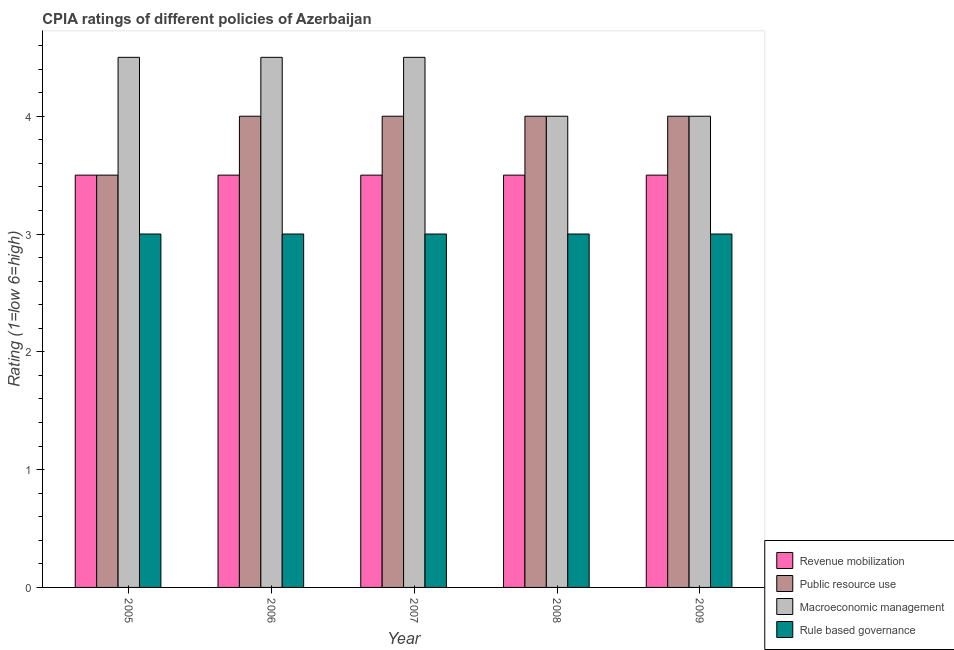How many different coloured bars are there?
Provide a succinct answer. 4. Are the number of bars per tick equal to the number of legend labels?
Make the answer very short. Yes. Are the number of bars on each tick of the X-axis equal?
Make the answer very short. Yes. What is the label of the 2nd group of bars from the left?
Provide a short and direct response. 2006. What is the cpia rating of revenue mobilization in 2006?
Offer a very short reply. 3.5. Across all years, what is the minimum cpia rating of rule based governance?
Provide a succinct answer. 3. What is the total cpia rating of public resource use in the graph?
Give a very brief answer. 19.5. What is the difference between the cpia rating of revenue mobilization in 2005 and the cpia rating of rule based governance in 2006?
Provide a succinct answer. 0. In how many years, is the cpia rating of rule based governance greater than 0.8?
Your answer should be compact. 5. What is the ratio of the cpia rating of public resource use in 2007 to that in 2009?
Provide a succinct answer. 1. Is the difference between the cpia rating of public resource use in 2005 and 2007 greater than the difference between the cpia rating of macroeconomic management in 2005 and 2007?
Provide a succinct answer. No. Is the sum of the cpia rating of public resource use in 2007 and 2008 greater than the maximum cpia rating of rule based governance across all years?
Offer a terse response. Yes. What does the 1st bar from the left in 2009 represents?
Offer a terse response. Revenue mobilization. What does the 1st bar from the right in 2008 represents?
Keep it short and to the point. Rule based governance. How many years are there in the graph?
Keep it short and to the point. 5. What is the difference between two consecutive major ticks on the Y-axis?
Provide a short and direct response. 1. Are the values on the major ticks of Y-axis written in scientific E-notation?
Offer a terse response. No. Does the graph contain grids?
Your response must be concise. No. How are the legend labels stacked?
Keep it short and to the point. Vertical. What is the title of the graph?
Your response must be concise. CPIA ratings of different policies of Azerbaijan. Does "Corruption" appear as one of the legend labels in the graph?
Your answer should be compact. No. What is the label or title of the X-axis?
Ensure brevity in your answer.  Year. What is the label or title of the Y-axis?
Make the answer very short. Rating (1=low 6=high). What is the Rating (1=low 6=high) of Revenue mobilization in 2005?
Ensure brevity in your answer.  3.5. What is the Rating (1=low 6=high) of Public resource use in 2005?
Offer a terse response. 3.5. What is the Rating (1=low 6=high) of Macroeconomic management in 2005?
Provide a short and direct response. 4.5. What is the Rating (1=low 6=high) of Macroeconomic management in 2006?
Offer a terse response. 4.5. What is the Rating (1=low 6=high) of Public resource use in 2008?
Provide a short and direct response. 4. What is the Rating (1=low 6=high) in Rule based governance in 2008?
Give a very brief answer. 3. What is the Rating (1=low 6=high) of Revenue mobilization in 2009?
Give a very brief answer. 3.5. What is the Rating (1=low 6=high) of Public resource use in 2009?
Make the answer very short. 4. Across all years, what is the maximum Rating (1=low 6=high) in Revenue mobilization?
Provide a short and direct response. 3.5. Across all years, what is the maximum Rating (1=low 6=high) of Public resource use?
Offer a very short reply. 4. Across all years, what is the maximum Rating (1=low 6=high) in Rule based governance?
Offer a very short reply. 3. Across all years, what is the minimum Rating (1=low 6=high) of Revenue mobilization?
Keep it short and to the point. 3.5. Across all years, what is the minimum Rating (1=low 6=high) in Macroeconomic management?
Your answer should be compact. 4. Across all years, what is the minimum Rating (1=low 6=high) in Rule based governance?
Ensure brevity in your answer.  3. What is the total Rating (1=low 6=high) of Revenue mobilization in the graph?
Offer a very short reply. 17.5. What is the total Rating (1=low 6=high) in Macroeconomic management in the graph?
Your response must be concise. 21.5. What is the total Rating (1=low 6=high) of Rule based governance in the graph?
Offer a very short reply. 15. What is the difference between the Rating (1=low 6=high) in Public resource use in 2005 and that in 2006?
Make the answer very short. -0.5. What is the difference between the Rating (1=low 6=high) in Macroeconomic management in 2005 and that in 2006?
Keep it short and to the point. 0. What is the difference between the Rating (1=low 6=high) of Macroeconomic management in 2005 and that in 2007?
Ensure brevity in your answer.  0. What is the difference between the Rating (1=low 6=high) in Rule based governance in 2005 and that in 2007?
Make the answer very short. 0. What is the difference between the Rating (1=low 6=high) in Revenue mobilization in 2005 and that in 2008?
Give a very brief answer. 0. What is the difference between the Rating (1=low 6=high) of Public resource use in 2005 and that in 2008?
Your response must be concise. -0.5. What is the difference between the Rating (1=low 6=high) in Macroeconomic management in 2005 and that in 2008?
Your answer should be very brief. 0.5. What is the difference between the Rating (1=low 6=high) of Public resource use in 2005 and that in 2009?
Keep it short and to the point. -0.5. What is the difference between the Rating (1=low 6=high) of Rule based governance in 2005 and that in 2009?
Your answer should be compact. 0. What is the difference between the Rating (1=low 6=high) of Public resource use in 2006 and that in 2007?
Your answer should be very brief. 0. What is the difference between the Rating (1=low 6=high) of Macroeconomic management in 2006 and that in 2007?
Your answer should be very brief. 0. What is the difference between the Rating (1=low 6=high) of Rule based governance in 2006 and that in 2007?
Keep it short and to the point. 0. What is the difference between the Rating (1=low 6=high) in Public resource use in 2006 and that in 2008?
Provide a short and direct response. 0. What is the difference between the Rating (1=low 6=high) of Macroeconomic management in 2006 and that in 2008?
Offer a terse response. 0.5. What is the difference between the Rating (1=low 6=high) of Rule based governance in 2006 and that in 2008?
Your answer should be very brief. 0. What is the difference between the Rating (1=low 6=high) in Macroeconomic management in 2006 and that in 2009?
Ensure brevity in your answer.  0.5. What is the difference between the Rating (1=low 6=high) of Rule based governance in 2006 and that in 2009?
Ensure brevity in your answer.  0. What is the difference between the Rating (1=low 6=high) of Macroeconomic management in 2007 and that in 2008?
Make the answer very short. 0.5. What is the difference between the Rating (1=low 6=high) in Revenue mobilization in 2007 and that in 2009?
Keep it short and to the point. 0. What is the difference between the Rating (1=low 6=high) of Public resource use in 2007 and that in 2009?
Keep it short and to the point. 0. What is the difference between the Rating (1=low 6=high) of Macroeconomic management in 2008 and that in 2009?
Make the answer very short. 0. What is the difference between the Rating (1=low 6=high) of Public resource use in 2005 and the Rating (1=low 6=high) of Macroeconomic management in 2006?
Give a very brief answer. -1. What is the difference between the Rating (1=low 6=high) of Public resource use in 2005 and the Rating (1=low 6=high) of Rule based governance in 2006?
Offer a terse response. 0.5. What is the difference between the Rating (1=low 6=high) of Public resource use in 2005 and the Rating (1=low 6=high) of Macroeconomic management in 2007?
Offer a terse response. -1. What is the difference between the Rating (1=low 6=high) in Public resource use in 2005 and the Rating (1=low 6=high) in Rule based governance in 2007?
Offer a very short reply. 0.5. What is the difference between the Rating (1=low 6=high) in Revenue mobilization in 2005 and the Rating (1=low 6=high) in Macroeconomic management in 2008?
Offer a terse response. -0.5. What is the difference between the Rating (1=low 6=high) in Revenue mobilization in 2005 and the Rating (1=low 6=high) in Rule based governance in 2008?
Offer a very short reply. 0.5. What is the difference between the Rating (1=low 6=high) of Revenue mobilization in 2005 and the Rating (1=low 6=high) of Public resource use in 2009?
Provide a short and direct response. -0.5. What is the difference between the Rating (1=low 6=high) of Revenue mobilization in 2005 and the Rating (1=low 6=high) of Rule based governance in 2009?
Offer a terse response. 0.5. What is the difference between the Rating (1=low 6=high) in Macroeconomic management in 2005 and the Rating (1=low 6=high) in Rule based governance in 2009?
Give a very brief answer. 1.5. What is the difference between the Rating (1=low 6=high) in Revenue mobilization in 2006 and the Rating (1=low 6=high) in Macroeconomic management in 2007?
Offer a terse response. -1. What is the difference between the Rating (1=low 6=high) of Revenue mobilization in 2006 and the Rating (1=low 6=high) of Public resource use in 2008?
Your response must be concise. -0.5. What is the difference between the Rating (1=low 6=high) of Revenue mobilization in 2006 and the Rating (1=low 6=high) of Macroeconomic management in 2008?
Your response must be concise. -0.5. What is the difference between the Rating (1=low 6=high) of Public resource use in 2006 and the Rating (1=low 6=high) of Macroeconomic management in 2008?
Give a very brief answer. 0. What is the difference between the Rating (1=low 6=high) of Revenue mobilization in 2006 and the Rating (1=low 6=high) of Macroeconomic management in 2009?
Make the answer very short. -0.5. What is the difference between the Rating (1=low 6=high) in Macroeconomic management in 2006 and the Rating (1=low 6=high) in Rule based governance in 2009?
Ensure brevity in your answer.  1.5. What is the difference between the Rating (1=low 6=high) of Revenue mobilization in 2007 and the Rating (1=low 6=high) of Macroeconomic management in 2008?
Your response must be concise. -0.5. What is the difference between the Rating (1=low 6=high) in Revenue mobilization in 2007 and the Rating (1=low 6=high) in Rule based governance in 2008?
Keep it short and to the point. 0.5. What is the difference between the Rating (1=low 6=high) of Public resource use in 2007 and the Rating (1=low 6=high) of Macroeconomic management in 2008?
Offer a very short reply. 0. What is the difference between the Rating (1=low 6=high) in Revenue mobilization in 2007 and the Rating (1=low 6=high) in Macroeconomic management in 2009?
Provide a succinct answer. -0.5. What is the difference between the Rating (1=low 6=high) in Revenue mobilization in 2007 and the Rating (1=low 6=high) in Rule based governance in 2009?
Your answer should be compact. 0.5. What is the difference between the Rating (1=low 6=high) in Macroeconomic management in 2007 and the Rating (1=low 6=high) in Rule based governance in 2009?
Offer a terse response. 1.5. What is the difference between the Rating (1=low 6=high) in Revenue mobilization in 2008 and the Rating (1=low 6=high) in Public resource use in 2009?
Keep it short and to the point. -0.5. What is the difference between the Rating (1=low 6=high) in Revenue mobilization in 2008 and the Rating (1=low 6=high) in Macroeconomic management in 2009?
Provide a short and direct response. -0.5. What is the difference between the Rating (1=low 6=high) of Macroeconomic management in 2008 and the Rating (1=low 6=high) of Rule based governance in 2009?
Offer a terse response. 1. What is the average Rating (1=low 6=high) of Public resource use per year?
Your answer should be very brief. 3.9. What is the average Rating (1=low 6=high) in Rule based governance per year?
Give a very brief answer. 3. In the year 2005, what is the difference between the Rating (1=low 6=high) of Revenue mobilization and Rating (1=low 6=high) of Public resource use?
Keep it short and to the point. 0. In the year 2005, what is the difference between the Rating (1=low 6=high) of Revenue mobilization and Rating (1=low 6=high) of Macroeconomic management?
Keep it short and to the point. -1. In the year 2005, what is the difference between the Rating (1=low 6=high) in Public resource use and Rating (1=low 6=high) in Rule based governance?
Provide a succinct answer. 0.5. In the year 2006, what is the difference between the Rating (1=low 6=high) of Revenue mobilization and Rating (1=low 6=high) of Public resource use?
Offer a terse response. -0.5. In the year 2006, what is the difference between the Rating (1=low 6=high) of Public resource use and Rating (1=low 6=high) of Macroeconomic management?
Your response must be concise. -0.5. In the year 2006, what is the difference between the Rating (1=low 6=high) of Macroeconomic management and Rating (1=low 6=high) of Rule based governance?
Your response must be concise. 1.5. In the year 2007, what is the difference between the Rating (1=low 6=high) in Revenue mobilization and Rating (1=low 6=high) in Public resource use?
Offer a terse response. -0.5. In the year 2007, what is the difference between the Rating (1=low 6=high) in Revenue mobilization and Rating (1=low 6=high) in Macroeconomic management?
Give a very brief answer. -1. In the year 2008, what is the difference between the Rating (1=low 6=high) of Revenue mobilization and Rating (1=low 6=high) of Public resource use?
Offer a terse response. -0.5. In the year 2008, what is the difference between the Rating (1=low 6=high) in Revenue mobilization and Rating (1=low 6=high) in Rule based governance?
Your response must be concise. 0.5. In the year 2008, what is the difference between the Rating (1=low 6=high) in Public resource use and Rating (1=low 6=high) in Macroeconomic management?
Your answer should be very brief. 0. In the year 2008, what is the difference between the Rating (1=low 6=high) of Macroeconomic management and Rating (1=low 6=high) of Rule based governance?
Your response must be concise. 1. In the year 2009, what is the difference between the Rating (1=low 6=high) of Revenue mobilization and Rating (1=low 6=high) of Rule based governance?
Provide a short and direct response. 0.5. In the year 2009, what is the difference between the Rating (1=low 6=high) of Public resource use and Rating (1=low 6=high) of Rule based governance?
Your response must be concise. 1. In the year 2009, what is the difference between the Rating (1=low 6=high) in Macroeconomic management and Rating (1=low 6=high) in Rule based governance?
Give a very brief answer. 1. What is the ratio of the Rating (1=low 6=high) of Revenue mobilization in 2005 to that in 2006?
Give a very brief answer. 1. What is the ratio of the Rating (1=low 6=high) of Public resource use in 2005 to that in 2006?
Make the answer very short. 0.88. What is the ratio of the Rating (1=low 6=high) in Public resource use in 2005 to that in 2007?
Provide a short and direct response. 0.88. What is the ratio of the Rating (1=low 6=high) of Macroeconomic management in 2005 to that in 2007?
Keep it short and to the point. 1. What is the ratio of the Rating (1=low 6=high) of Public resource use in 2005 to that in 2008?
Your answer should be very brief. 0.88. What is the ratio of the Rating (1=low 6=high) in Macroeconomic management in 2005 to that in 2008?
Your answer should be very brief. 1.12. What is the ratio of the Rating (1=low 6=high) in Rule based governance in 2005 to that in 2008?
Provide a succinct answer. 1. What is the ratio of the Rating (1=low 6=high) in Rule based governance in 2005 to that in 2009?
Your answer should be compact. 1. What is the ratio of the Rating (1=low 6=high) of Public resource use in 2006 to that in 2007?
Offer a very short reply. 1. What is the ratio of the Rating (1=low 6=high) of Revenue mobilization in 2006 to that in 2008?
Keep it short and to the point. 1. What is the ratio of the Rating (1=low 6=high) of Public resource use in 2006 to that in 2008?
Ensure brevity in your answer.  1. What is the ratio of the Rating (1=low 6=high) in Macroeconomic management in 2006 to that in 2008?
Keep it short and to the point. 1.12. What is the ratio of the Rating (1=low 6=high) in Public resource use in 2006 to that in 2009?
Provide a succinct answer. 1. What is the ratio of the Rating (1=low 6=high) in Macroeconomic management in 2006 to that in 2009?
Offer a terse response. 1.12. What is the ratio of the Rating (1=low 6=high) in Revenue mobilization in 2007 to that in 2008?
Provide a succinct answer. 1. What is the ratio of the Rating (1=low 6=high) of Public resource use in 2007 to that in 2008?
Offer a very short reply. 1. What is the ratio of the Rating (1=low 6=high) in Rule based governance in 2007 to that in 2008?
Keep it short and to the point. 1. What is the ratio of the Rating (1=low 6=high) of Public resource use in 2007 to that in 2009?
Offer a terse response. 1. What is the ratio of the Rating (1=low 6=high) of Macroeconomic management in 2007 to that in 2009?
Keep it short and to the point. 1.12. What is the ratio of the Rating (1=low 6=high) of Revenue mobilization in 2008 to that in 2009?
Make the answer very short. 1. What is the ratio of the Rating (1=low 6=high) in Public resource use in 2008 to that in 2009?
Offer a terse response. 1. What is the ratio of the Rating (1=low 6=high) of Macroeconomic management in 2008 to that in 2009?
Give a very brief answer. 1. What is the ratio of the Rating (1=low 6=high) of Rule based governance in 2008 to that in 2009?
Make the answer very short. 1. What is the difference between the highest and the lowest Rating (1=low 6=high) in Public resource use?
Provide a succinct answer. 0.5. What is the difference between the highest and the lowest Rating (1=low 6=high) in Macroeconomic management?
Provide a short and direct response. 0.5. What is the difference between the highest and the lowest Rating (1=low 6=high) in Rule based governance?
Make the answer very short. 0. 